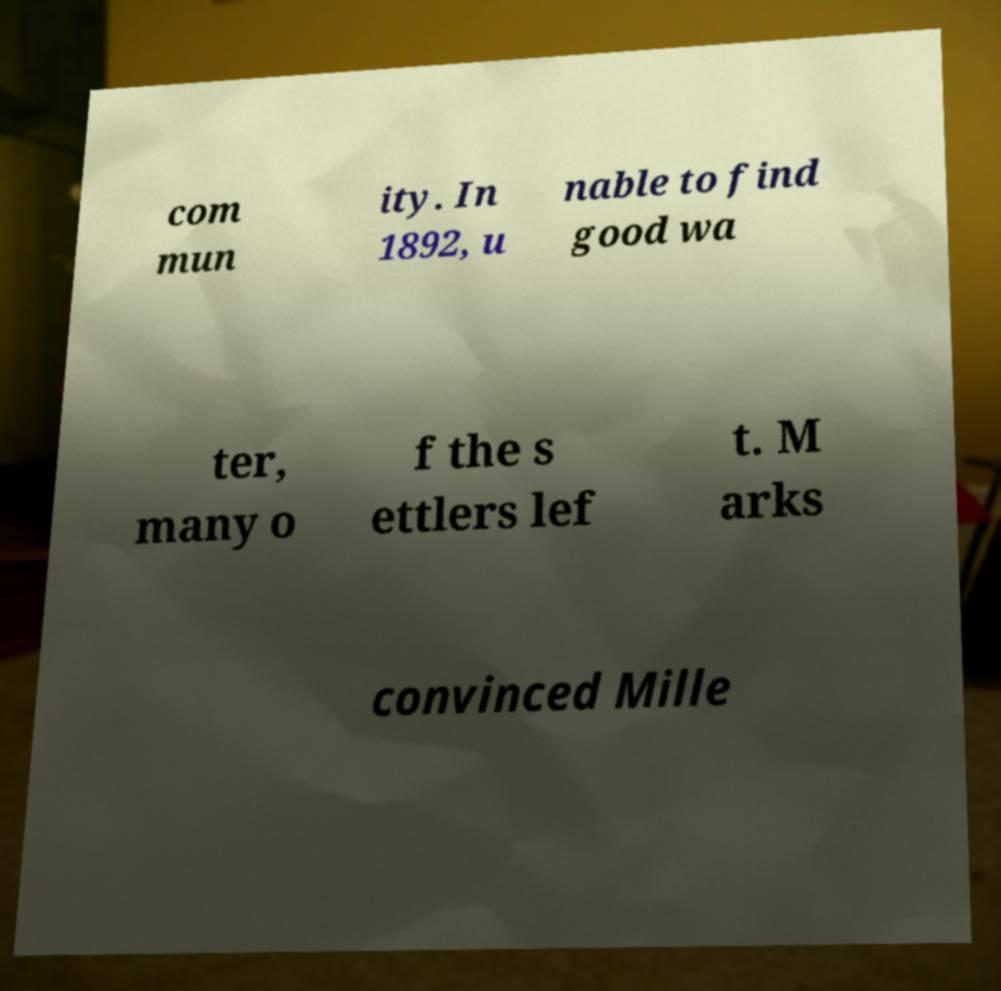What messages or text are displayed in this image? I need them in a readable, typed format. com mun ity. In 1892, u nable to find good wa ter, many o f the s ettlers lef t. M arks convinced Mille 